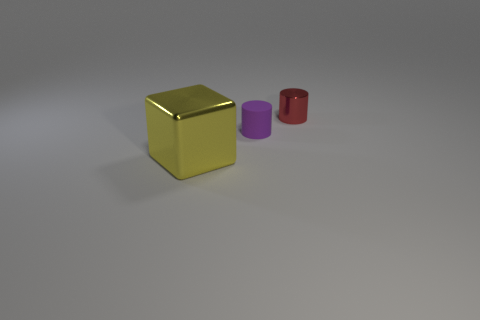Add 2 small red objects. How many objects exist? 5 Subtract all cubes. How many objects are left? 2 Add 1 tiny things. How many tiny things exist? 3 Subtract 0 yellow balls. How many objects are left? 3 Subtract all small purple cylinders. Subtract all purple things. How many objects are left? 1 Add 2 tiny red objects. How many tiny red objects are left? 3 